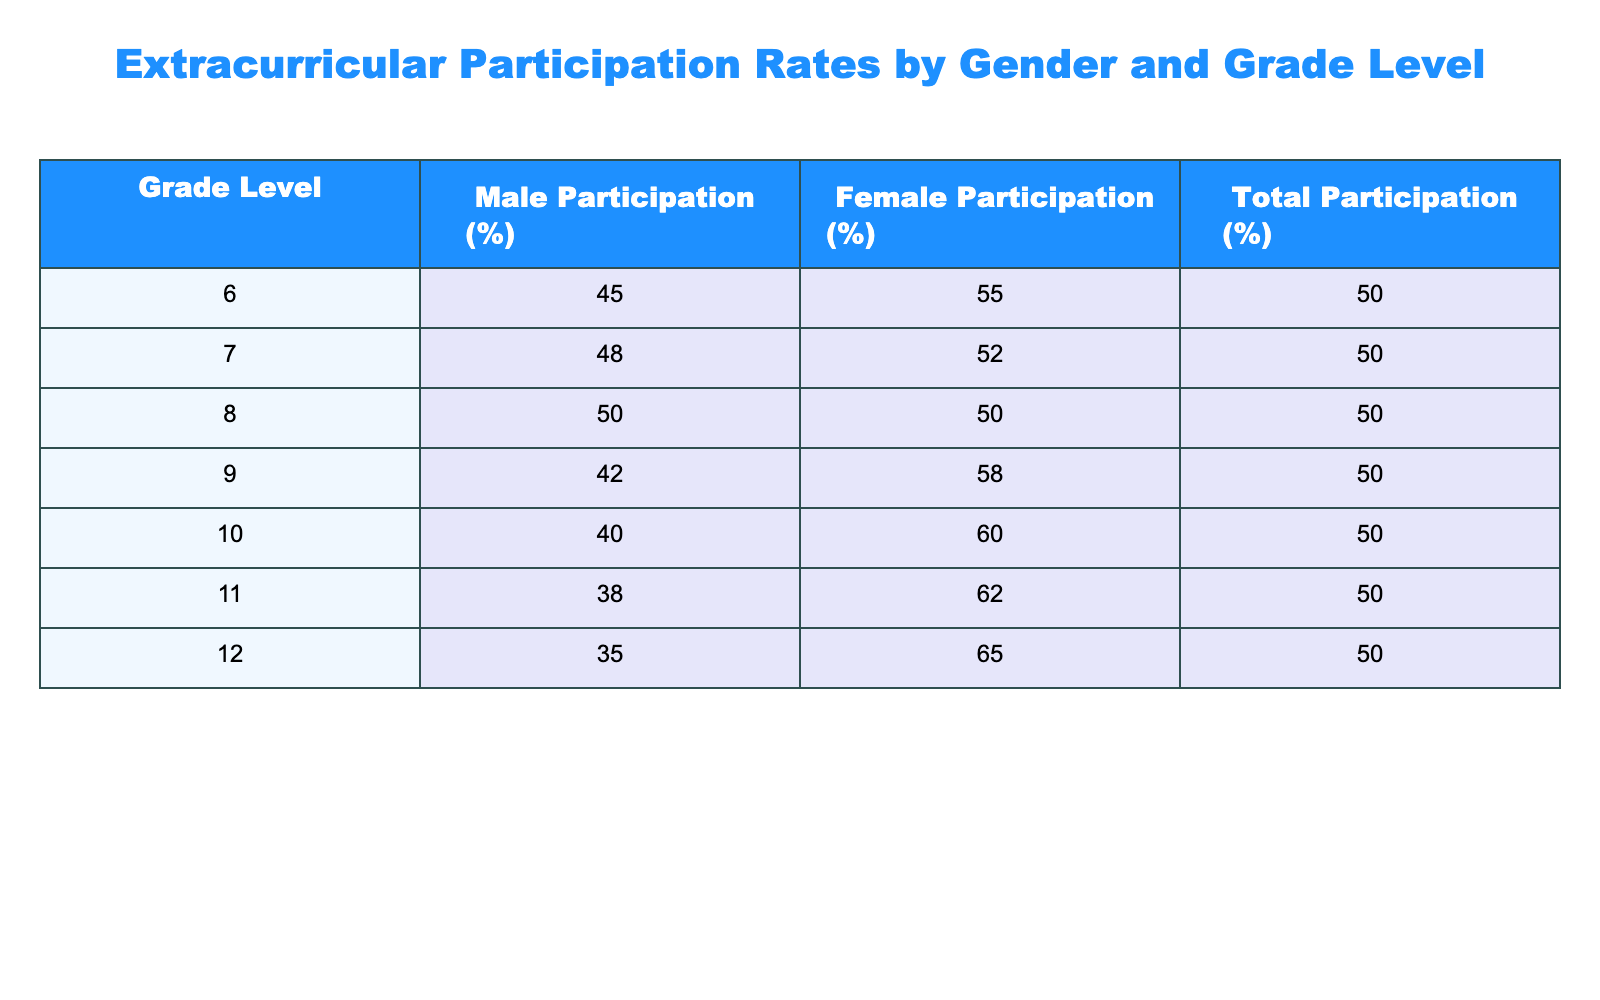What is the participation rate of male students in grade 6? From the table, the participation rate for male students in grade 6 is listed directly under the Male Participation (%) column, which shows 45%.
Answer: 45 What is the total participation rate for grade 10? The total participation rate for grade 10 is found in the Total Participation (%) column. For grade 10, this value is 50%.
Answer: 50 What is the average female participation rate across all grade levels? To find the average, we add the female participation rates for all grades: 55 + 52 + 50 + 58 + 60 + 62 + 65 = 408. Then we divide by the number of grades, which is 7: 408/7 = approximately 58.29.
Answer: 58.29 Is the male participation rate for grade 11 higher than that for grade 12? The male participation rate for grade 11 is 38%, while for grade 12, it is 35%. Since 38% is greater than 35%, the statement is true.
Answer: Yes What is the difference in female participation rates between grade 9 and grade 11? The female participation rate for grade 9 is 58%, and for grade 11, it is 62%. To find the difference, we subtract: 62 - 58 = 4%.
Answer: 4 If the total participation rates are all equal across grades, what would be the average male participation rate? The table shows that the total participation rates are all 50%. The male participation rates have values of 45, 48, 50, 42, 40, 38, and 35. To find the average, we add these values: 45 + 48 + 50 + 42 + 40 + 38 + 35 = 298, then divide by 7: 298/7 = approximately 42.57.
Answer: 42.57 Does female participation rate decline as students progress from grade 6 to grade 12? Checking the female participation rates from grades 6 to 12, we find 55% (grade 6), 52% (grade 7), 50% (grade 8), 58% (grade 9), 60% (grade 10), 62% (grade 11), and 65% (grade 12). The trend shows increases overall, thus, the statement is false.
Answer: No What is the combined female participation rate for grades 6 and 7? The female participation rates are 55% for grade 6 and 52% for grade 7. Adding these together gives 55 + 52 = 107%. This represents a combined rate for the two grades.
Answer: 107 